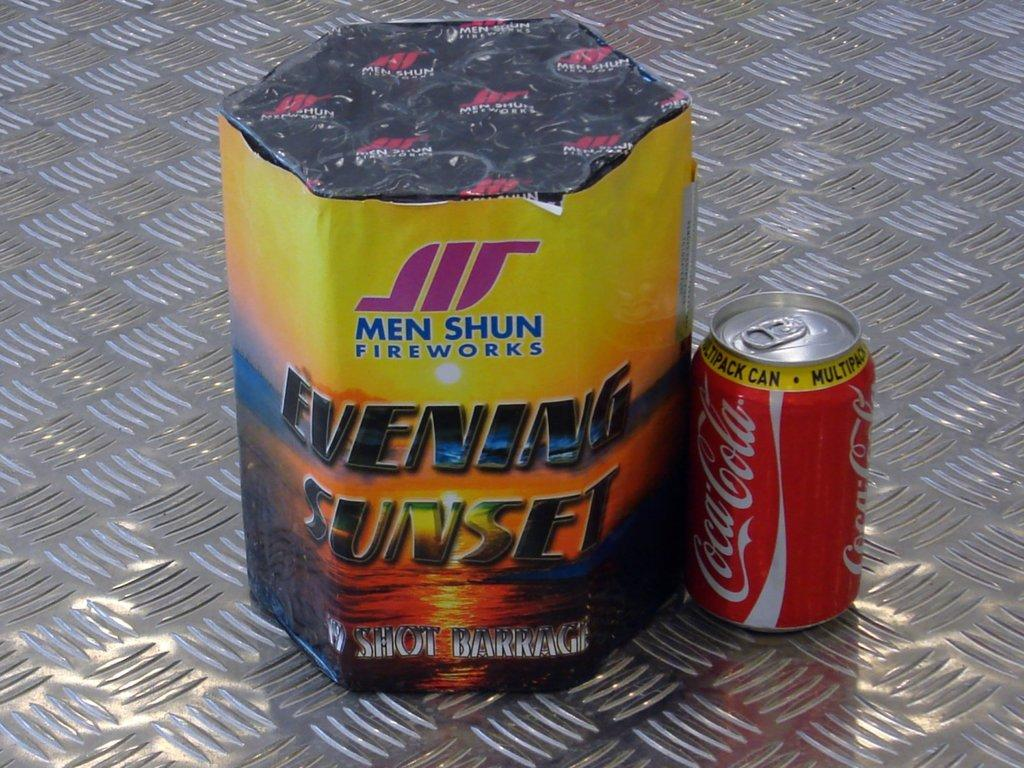<image>
Write a terse but informative summary of the picture. Celebration items for the 4th of July, Men Shun Fireworks and a Coca Cola Soda Can. 